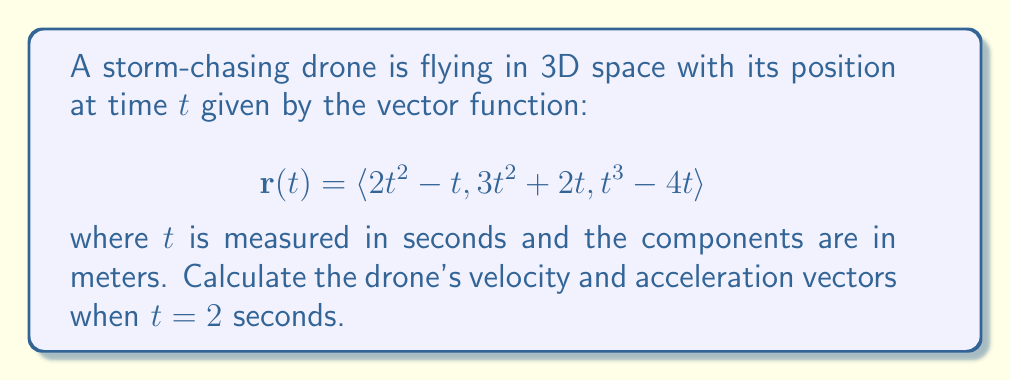Can you answer this question? To solve this problem, we need to find the velocity and acceleration vectors by differentiating the position vector.

Step 1: Calculate the velocity vector
The velocity vector is the first derivative of the position vector:
$$\mathbf{v}(t) = \frac{d}{dt}\mathbf{r}(t) = \langle \frac{d}{dt}(2t^2 - t), \frac{d}{dt}(3t^2 + 2t), \frac{d}{dt}(t^3 - 4t) \rangle$$

$$\mathbf{v}(t) = \langle 4t - 1, 6t + 2, 3t^2 - 4 \rangle$$

Step 2: Calculate the acceleration vector
The acceleration vector is the second derivative of the position vector or the first derivative of the velocity vector:
$$\mathbf{a}(t) = \frac{d}{dt}\mathbf{v}(t) = \langle \frac{d}{dt}(4t - 1), \frac{d}{dt}(6t + 2), \frac{d}{dt}(3t^2 - 4) \rangle$$

$$\mathbf{a}(t) = \langle 4, 6, 6t \rangle$$

Step 3: Evaluate velocity and acceleration at $t = 2$ seconds
Velocity at $t = 2$:
$$\mathbf{v}(2) = \langle 4(2) - 1, 6(2) + 2, 3(2)^2 - 4 \rangle = \langle 7, 14, 8 \rangle$$

Acceleration at $t = 2$:
$$\mathbf{a}(2) = \langle 4, 6, 6(2) \rangle = \langle 4, 6, 12 \rangle$$
Answer: Velocity: $\langle 7, 14, 8 \rangle$ m/s; Acceleration: $\langle 4, 6, 12 \rangle$ m/s² 